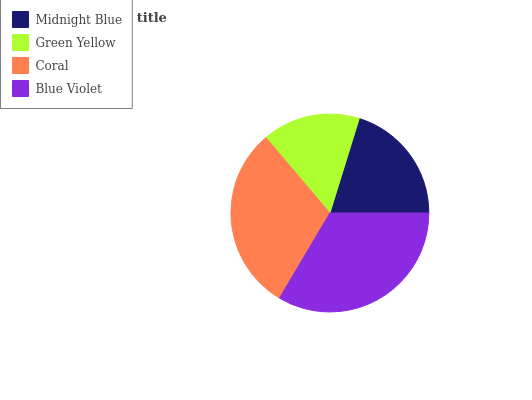Is Green Yellow the minimum?
Answer yes or no. Yes. Is Blue Violet the maximum?
Answer yes or no. Yes. Is Coral the minimum?
Answer yes or no. No. Is Coral the maximum?
Answer yes or no. No. Is Coral greater than Green Yellow?
Answer yes or no. Yes. Is Green Yellow less than Coral?
Answer yes or no. Yes. Is Green Yellow greater than Coral?
Answer yes or no. No. Is Coral less than Green Yellow?
Answer yes or no. No. Is Coral the high median?
Answer yes or no. Yes. Is Midnight Blue the low median?
Answer yes or no. Yes. Is Blue Violet the high median?
Answer yes or no. No. Is Green Yellow the low median?
Answer yes or no. No. 